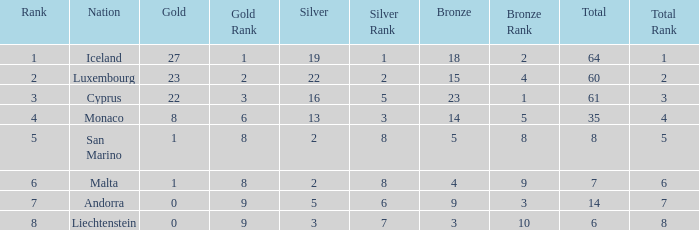How many bronzes for nations with over 22 golds and ranked under 2? 18.0. Give me the full table as a dictionary. {'header': ['Rank', 'Nation', 'Gold', 'Gold Rank', 'Silver', 'Silver Rank', 'Bronze', 'Bronze Rank', 'Total', 'Total Rank'], 'rows': [['1', 'Iceland', '27', '1', '19', '1', '18', '2', '64', '1'], ['2', 'Luxembourg', '23', '2', '22', '2', '15', '4', '60', '2'], ['3', 'Cyprus', '22', '3', '16', '5', '23', '1', '61', '3'], ['4', 'Monaco', '8', '6', '13', '3', '14', '5', '35', '4'], ['5', 'San Marino', '1', '8', '2', '8', '5', '8', '8', '5'], ['6', 'Malta', '1', '8', '2', '8', '4', '9', '7', '6'], ['7', 'Andorra', '0', '9', '5', '6', '9', '3', '14', '7'], ['8', 'Liechtenstein', '0', '9', '3', '7', '3', '10', '6', '8']]} 